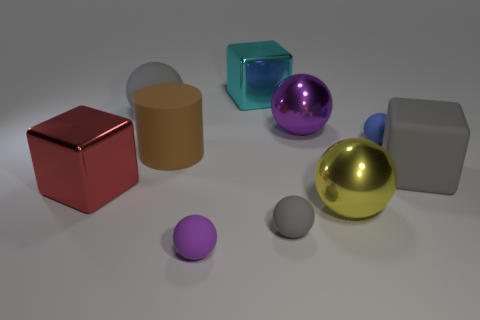Subtract all gray balls. How many balls are left? 4 Subtract all blue balls. How many balls are left? 5 Subtract 2 balls. How many balls are left? 4 Subtract all green balls. Subtract all cyan blocks. How many balls are left? 6 Subtract all blocks. How many objects are left? 7 Add 4 cyan metal blocks. How many cyan metal blocks exist? 5 Subtract 0 purple cylinders. How many objects are left? 10 Subtract all large blue rubber spheres. Subtract all cylinders. How many objects are left? 9 Add 2 gray rubber spheres. How many gray rubber spheres are left? 4 